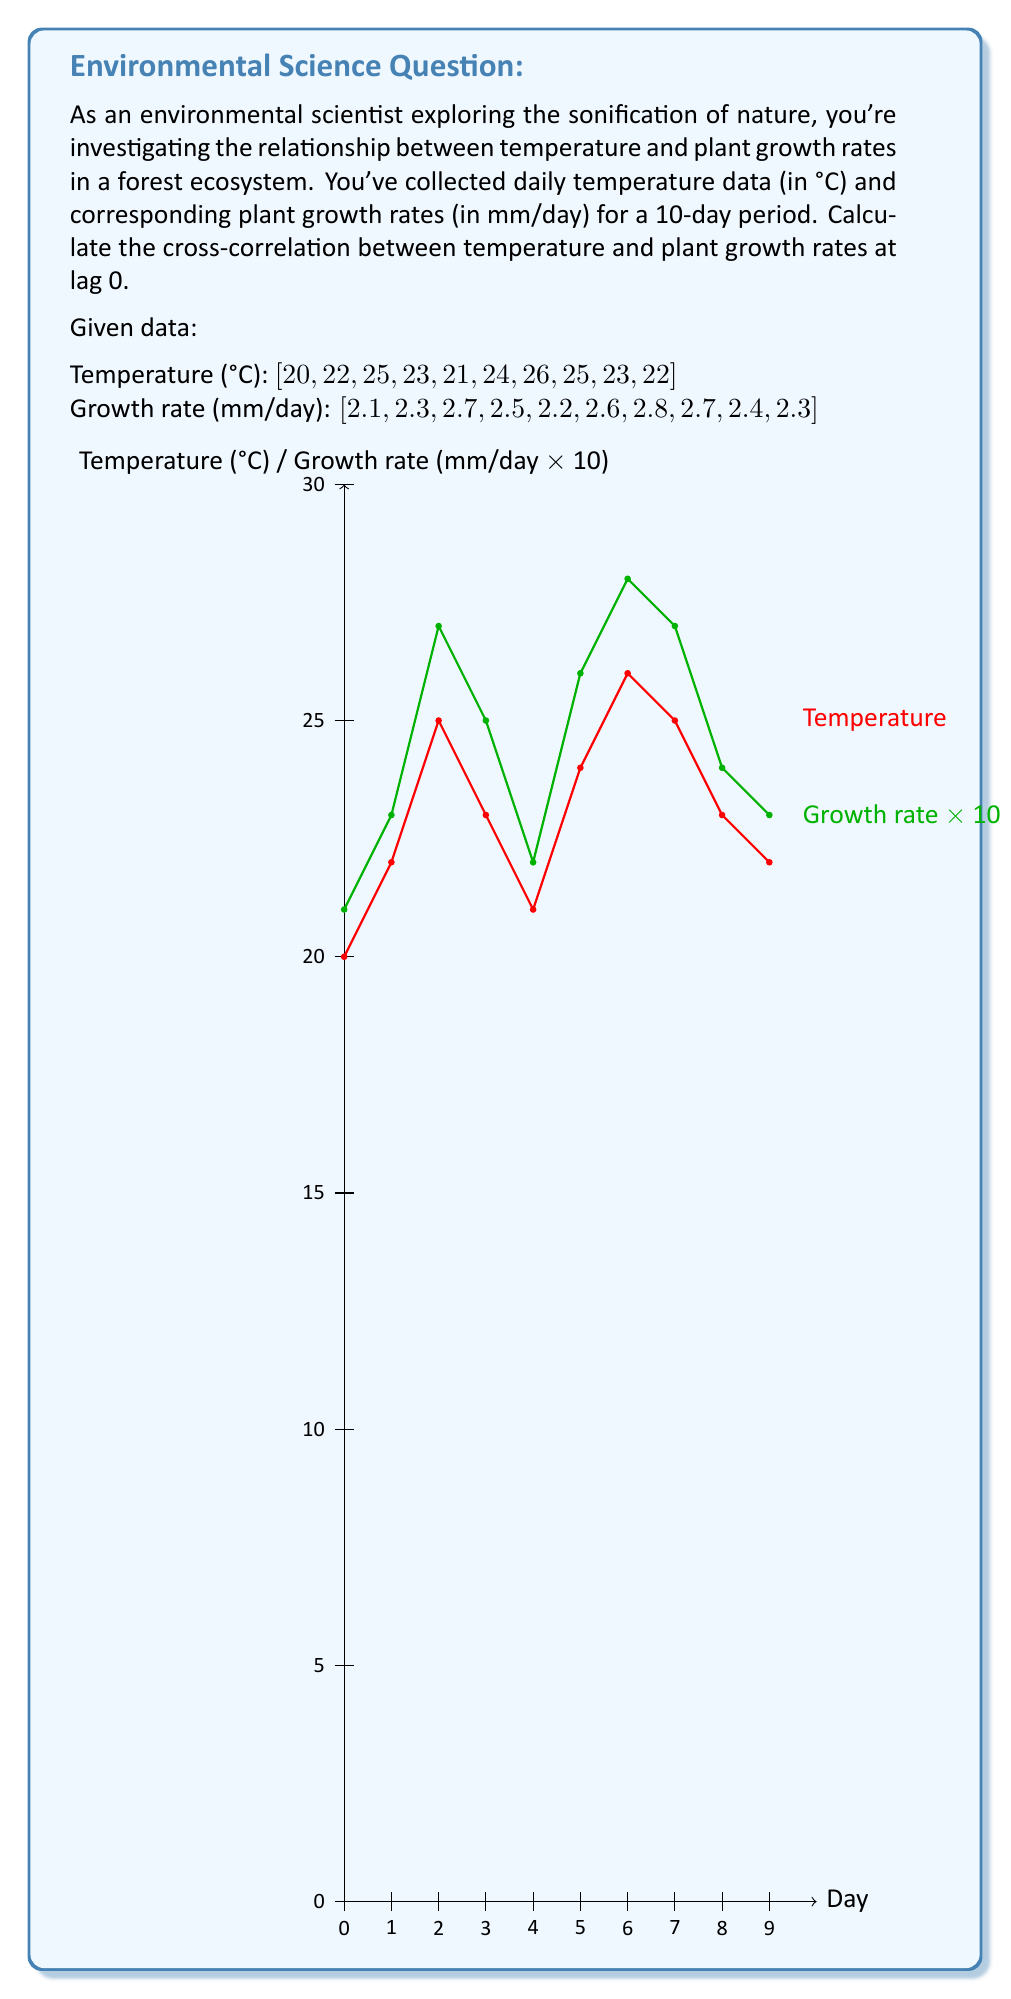Solve this math problem. To calculate the cross-correlation between temperature and plant growth rates at lag 0, we'll follow these steps:

1. Calculate the means of both series:
   $$\bar{x} = \frac{1}{N}\sum_{i=1}^N x_i$$
   $$\bar{y} = \frac{1}{N}\sum_{i=1}^N y_i$$

   Temperature mean: $\bar{x} = \frac{20 + 22 + 25 + 23 + 21 + 24 + 26 + 25 + 23 + 22}{10} = 23.1$
   Growth rate mean: $\bar{y} = \frac{2.1 + 2.3 + 2.7 + 2.5 + 2.2 + 2.6 + 2.8 + 2.7 + 2.4 + 2.3}{10} = 2.46$

2. Calculate the standard deviations of both series:
   $$s_x = \sqrt{\frac{1}{N-1}\sum_{i=1}^N (x_i - \bar{x})^2}$$
   $$s_y = \sqrt{\frac{1}{N-1}\sum_{i=1}^N (y_i - \bar{y})^2}$$

   Temperature std dev: $s_x = 1.912$
   Growth rate std dev: $s_y = 0.238$

3. Calculate the cross-correlation at lag 0:
   $$r_{xy}(0) = \frac{1}{N}\sum_{i=1}^N \frac{(x_i - \bar{x})(y_i - \bar{y})}{s_x s_y}$$

   $r_{xy}(0) = \frac{1}{10} \cdot \frac{1}{1.912 \cdot 0.238} \cdot [(20 - 23.1)(2.1 - 2.46) + ... + (22 - 23.1)(2.3 - 2.46)]$

4. Compute the sum of the products:
   $\sum_{i=1}^N (x_i - \bar{x})(y_i - \bar{y}) = 3.91$

5. Substitute into the formula:
   $r_{xy}(0) = \frac{1}{10} \cdot \frac{3.91}{1.912 \cdot 0.238} = 0.858$

The cross-correlation at lag 0 is 0.858, indicating a strong positive correlation between temperature and plant growth rates.
Answer: 0.858 